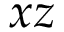Convert formula to latex. <formula><loc_0><loc_0><loc_500><loc_500>x z</formula> 